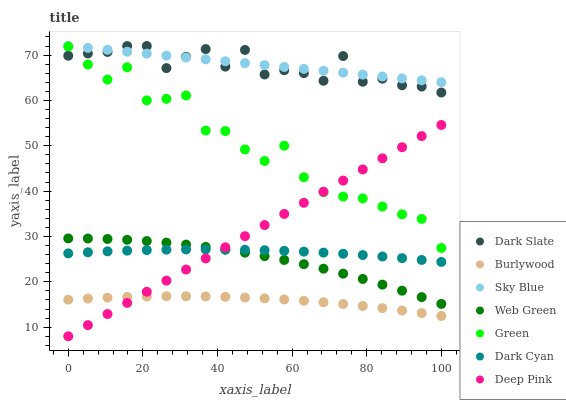Does Burlywood have the minimum area under the curve?
Answer yes or no. Yes. Does Sky Blue have the maximum area under the curve?
Answer yes or no. Yes. Does Web Green have the minimum area under the curve?
Answer yes or no. No. Does Web Green have the maximum area under the curve?
Answer yes or no. No. Is Deep Pink the smoothest?
Answer yes or no. Yes. Is Green the roughest?
Answer yes or no. Yes. Is Burlywood the smoothest?
Answer yes or no. No. Is Burlywood the roughest?
Answer yes or no. No. Does Deep Pink have the lowest value?
Answer yes or no. Yes. Does Burlywood have the lowest value?
Answer yes or no. No. Does Sky Blue have the highest value?
Answer yes or no. Yes. Does Web Green have the highest value?
Answer yes or no. No. Is Green less than Sky Blue?
Answer yes or no. Yes. Is Dark Slate greater than Web Green?
Answer yes or no. Yes. Does Web Green intersect Deep Pink?
Answer yes or no. Yes. Is Web Green less than Deep Pink?
Answer yes or no. No. Is Web Green greater than Deep Pink?
Answer yes or no. No. Does Green intersect Sky Blue?
Answer yes or no. No. 